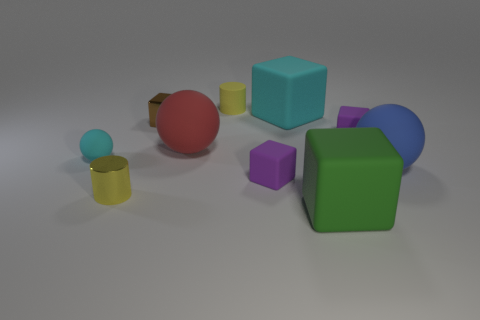Subtract all purple cubes. How many cubes are left? 3 Subtract all green blocks. How many blocks are left? 4 Subtract all cyan cubes. Subtract all green cylinders. How many cubes are left? 4 Subtract 0 brown balls. How many objects are left? 10 Subtract all cylinders. How many objects are left? 8 Subtract all brown shiny objects. Subtract all big rubber things. How many objects are left? 5 Add 7 tiny metal blocks. How many tiny metal blocks are left? 8 Add 6 blue cylinders. How many blue cylinders exist? 6 